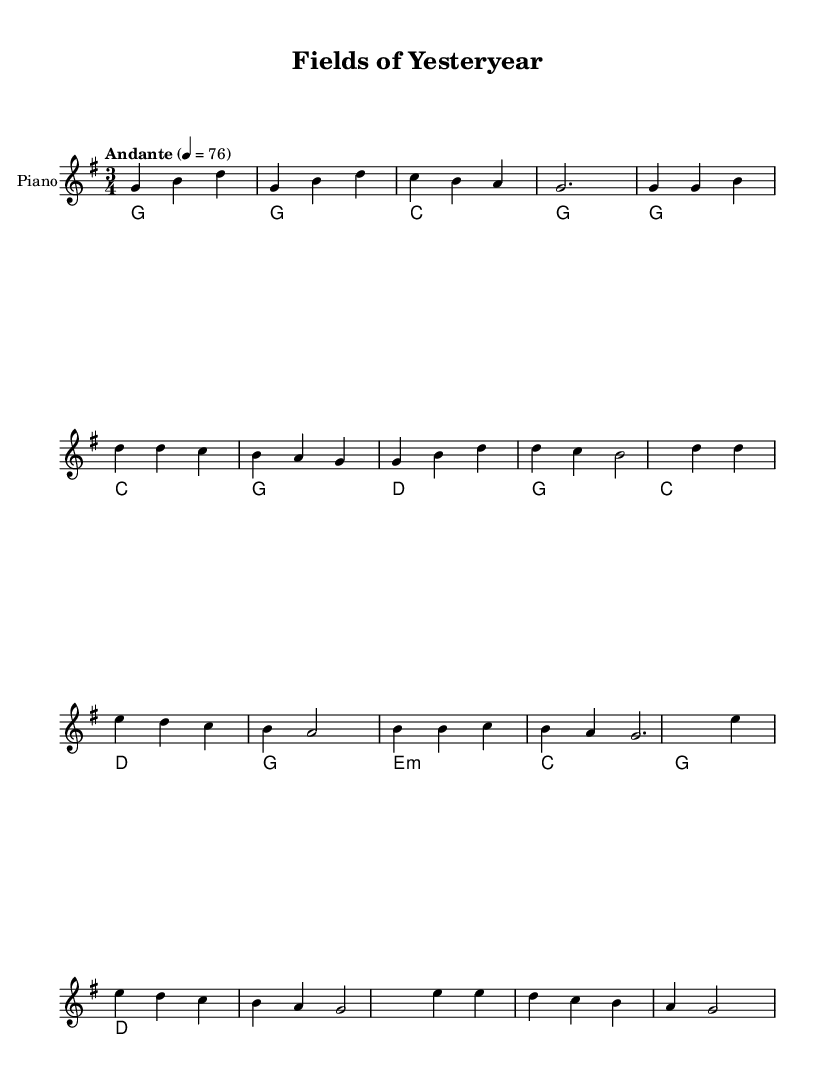What is the key signature of this music? The key signature is G major, which has one sharp (F#). This can be determined by looking for the key signature indicated at the beginning of the sheet music.
Answer: G major What is the time signature of this music? The time signature is 3/4, as indicated at the start of the piece. This means there are three beats in each measure and the quarter note gets one beat.
Answer: 3/4 What is the tempo marking of this music? The tempo marking is "Andante," which suggests a moderate walking pace. This is noted at the beginning of the score along with the metronome marking of 76.
Answer: Andante How many measures are in the chorus section? The chorus section consists of four measures, as counted from the start of the chorus to its end. Each grouping of notes within the slurs indicates a measure.
Answer: 4 What chord does the music start with? The music starts with the G major chord, as indicated in the harmonies section. This chord is the first one listed in the chord progressions at the beginning.
Answer: G What is the mood of the piece based on its musical features? The mood of the piece can be described as nostalgic, which is reflected in the gentle tempo, the 3/4 time signature, and the melodic phrases that evoke memories of rural life. This understanding comes from considering the type of ballad and its pastoral themes.
Answer: Nostalgic How does the bridge differ from the verse in terms of melody? The bridge features higher notes and introduces a descending melodic line that differs from the verse, which uses lower and more repetitive notes. This is inferred by comparing the melodic lines, where the bridge explores a different intervallic approach, adding contrast to the section.
Answer: Higher notes 